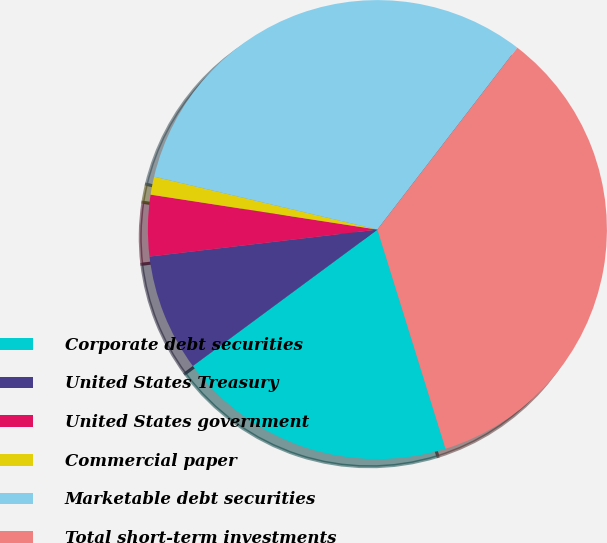<chart> <loc_0><loc_0><loc_500><loc_500><pie_chart><fcel>Corporate debt securities<fcel>United States Treasury<fcel>United States government<fcel>Commercial paper<fcel>Marketable debt securities<fcel>Total short-term investments<nl><fcel>19.67%<fcel>8.25%<fcel>4.31%<fcel>1.27%<fcel>31.73%<fcel>34.77%<nl></chart> 